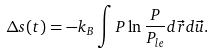Convert formula to latex. <formula><loc_0><loc_0><loc_500><loc_500>\Delta s ( t ) = - k _ { B } \int P \ln \frac { P } { P _ { l e } } d \vec { r } d \vec { u } .</formula> 